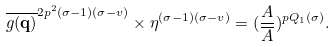<formula> <loc_0><loc_0><loc_500><loc_500>\overline { g ( \mathbf q ) } ^ { 2 p ^ { 2 } ( \sigma - 1 ) ( \sigma - v ) } \times \eta ^ { ( \sigma - 1 ) ( \sigma - v ) } = ( \frac { A } { \overline { A } } ) ^ { p Q _ { 1 } ( \sigma ) } .</formula> 